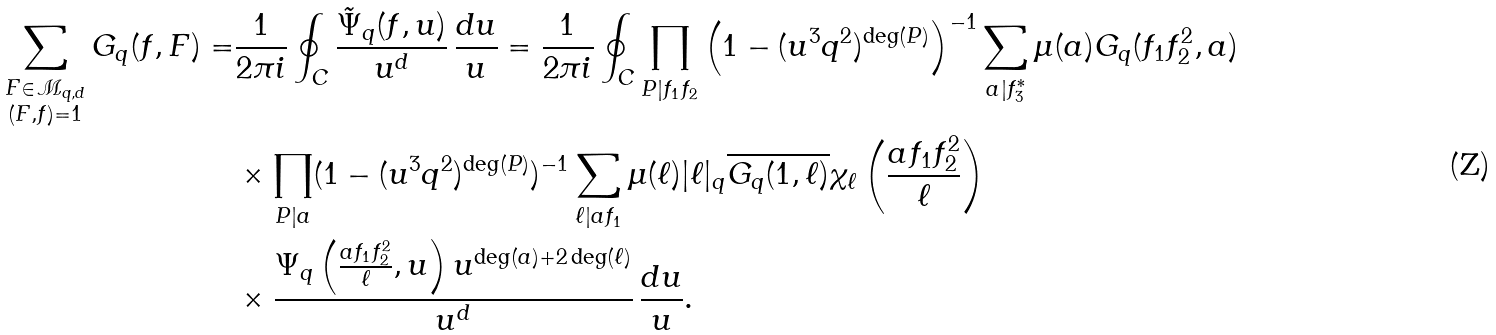<formula> <loc_0><loc_0><loc_500><loc_500>\sum _ { \substack { F \in \mathcal { M } _ { q , d } \\ ( F , f ) = 1 } } G _ { q } ( f , F ) = & \frac { 1 } { 2 \pi i } \oint _ { C } \frac { \tilde { \Psi } _ { q } ( f , u ) } { u ^ { d } } \, \frac { d u } { u } = \frac { 1 } { 2 \pi i } \oint _ { C } \prod _ { P | f _ { 1 } f _ { 2 } } \left ( 1 - ( u ^ { 3 } q ^ { 2 } ) ^ { \deg ( P ) } \right ) ^ { - 1 } \sum _ { a | f _ { 3 } ^ { * } } \mu ( a ) G _ { q } ( f _ { 1 } f _ { 2 } ^ { 2 } , a ) \\ & \times \prod _ { P | a } ( 1 - ( u ^ { 3 } q ^ { 2 } ) ^ { \deg ( P ) } ) ^ { - 1 } \sum _ { \ell | a f _ { 1 } } \mu ( \ell ) | \ell | _ { q } \overline { G _ { q } ( 1 , \ell ) } \chi _ { \ell } \left ( \frac { a f _ { 1 } f _ { 2 } ^ { 2 } } { \ell } \right ) \\ & \times \frac { \Psi _ { q } \left ( \frac { a f _ { 1 } f _ { 2 } ^ { 2 } } { \ell } , u \right ) u ^ { \deg ( a ) + 2 \deg ( \ell ) } } { u ^ { d } } \, \frac { d u } { u } .</formula> 